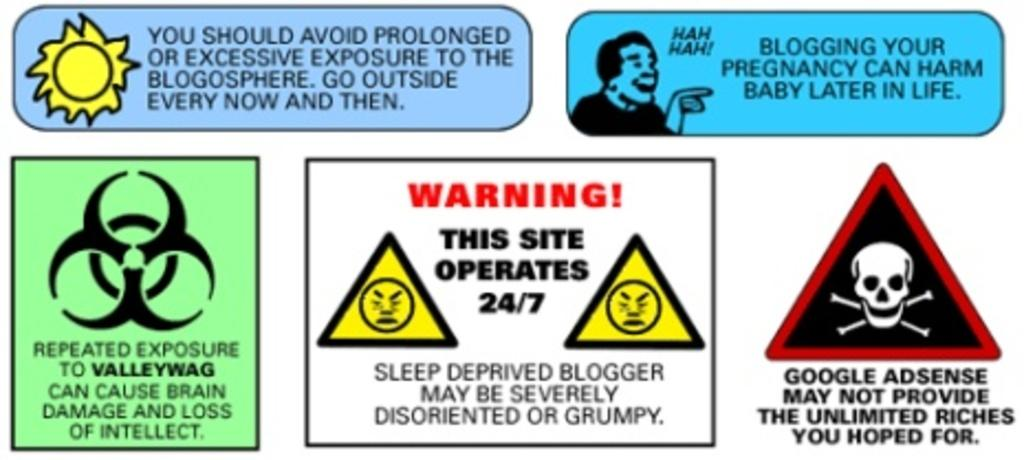What is present on the poster in the image? The poster contains sign symbols and warnings. What else can be found on the poster besides the symbols and warnings? There is text on the poster. What type of van is parked next to the poster in the image? There is no van present in the image; it only features a poster with sign symbols, warnings, and text. How many pages does the poster have in the image? The poster is a single image or piece of paper, so it does not have multiple pages. 